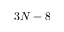<formula> <loc_0><loc_0><loc_500><loc_500>3 N - 8</formula> 